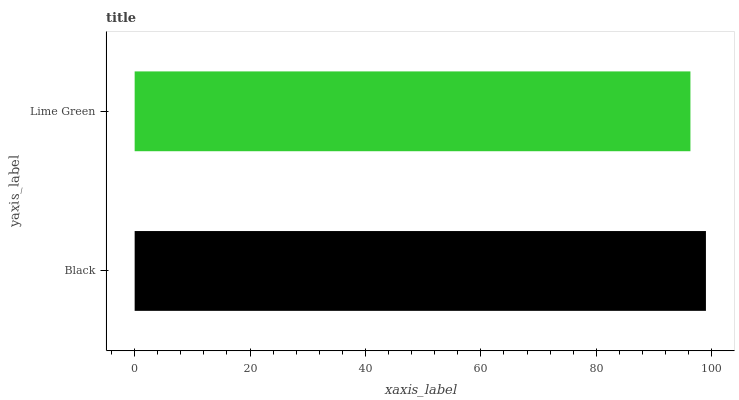Is Lime Green the minimum?
Answer yes or no. Yes. Is Black the maximum?
Answer yes or no. Yes. Is Lime Green the maximum?
Answer yes or no. No. Is Black greater than Lime Green?
Answer yes or no. Yes. Is Lime Green less than Black?
Answer yes or no. Yes. Is Lime Green greater than Black?
Answer yes or no. No. Is Black less than Lime Green?
Answer yes or no. No. Is Black the high median?
Answer yes or no. Yes. Is Lime Green the low median?
Answer yes or no. Yes. Is Lime Green the high median?
Answer yes or no. No. Is Black the low median?
Answer yes or no. No. 